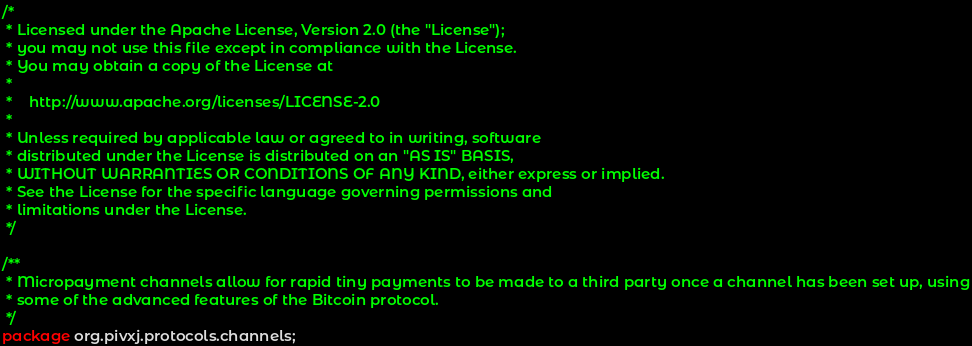<code> <loc_0><loc_0><loc_500><loc_500><_Java_>/*
 * Licensed under the Apache License, Version 2.0 (the "License");
 * you may not use this file except in compliance with the License.
 * You may obtain a copy of the License at
 *
 *    http://www.apache.org/licenses/LICENSE-2.0
 *
 * Unless required by applicable law or agreed to in writing, software
 * distributed under the License is distributed on an "AS IS" BASIS,
 * WITHOUT WARRANTIES OR CONDITIONS OF ANY KIND, either express or implied.
 * See the License for the specific language governing permissions and
 * limitations under the License.
 */

/**
 * Micropayment channels allow for rapid tiny payments to be made to a third party once a channel has been set up, using
 * some of the advanced features of the Bitcoin protocol.
 */
package org.pivxj.protocols.channels;</code> 